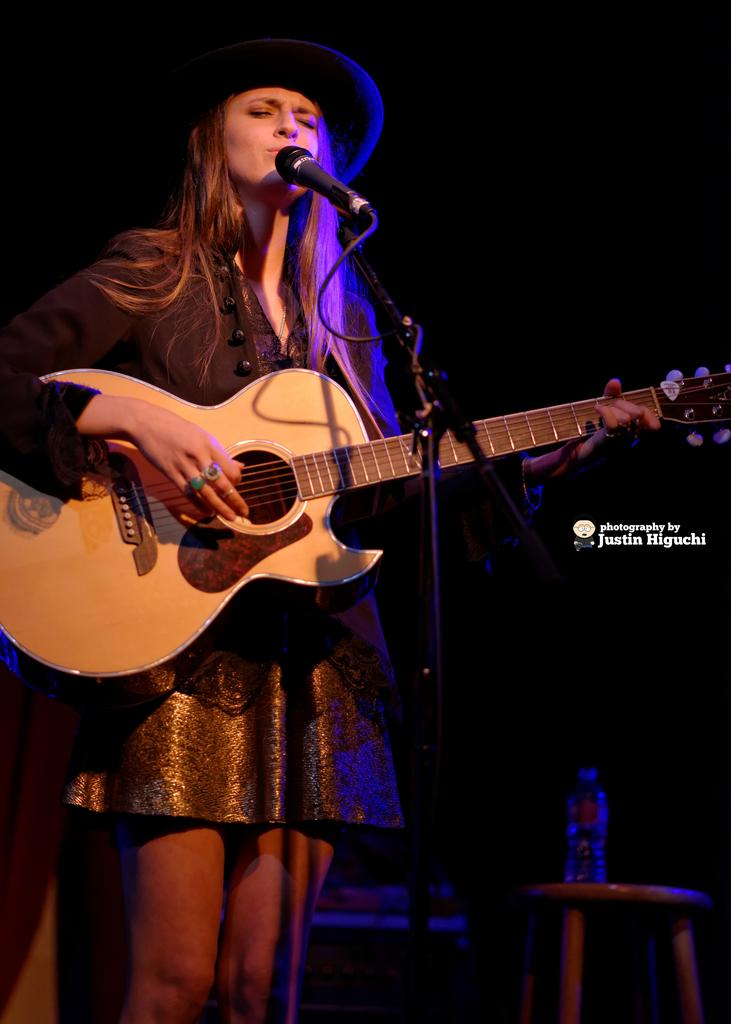Who is the main subject in the image? There is a woman in the image. What is the woman doing in the image? The woman is singing and playing a guitar. What object is the woman holding in the image? The woman is holding a microphone. What type of drum is the woman playing in the image? There is no drum present in the image; the woman is playing a guitar. 